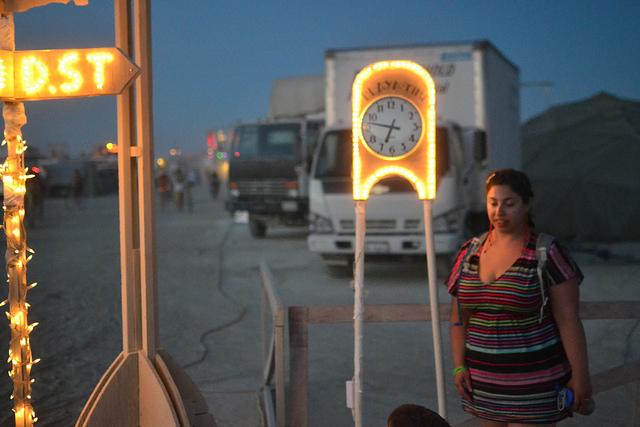What pattern is her dress?
Short answer required. Stripes. Is the woman wearing a backpack?
Quick response, please. Yes. What time is it?
Give a very brief answer. 6:47. 